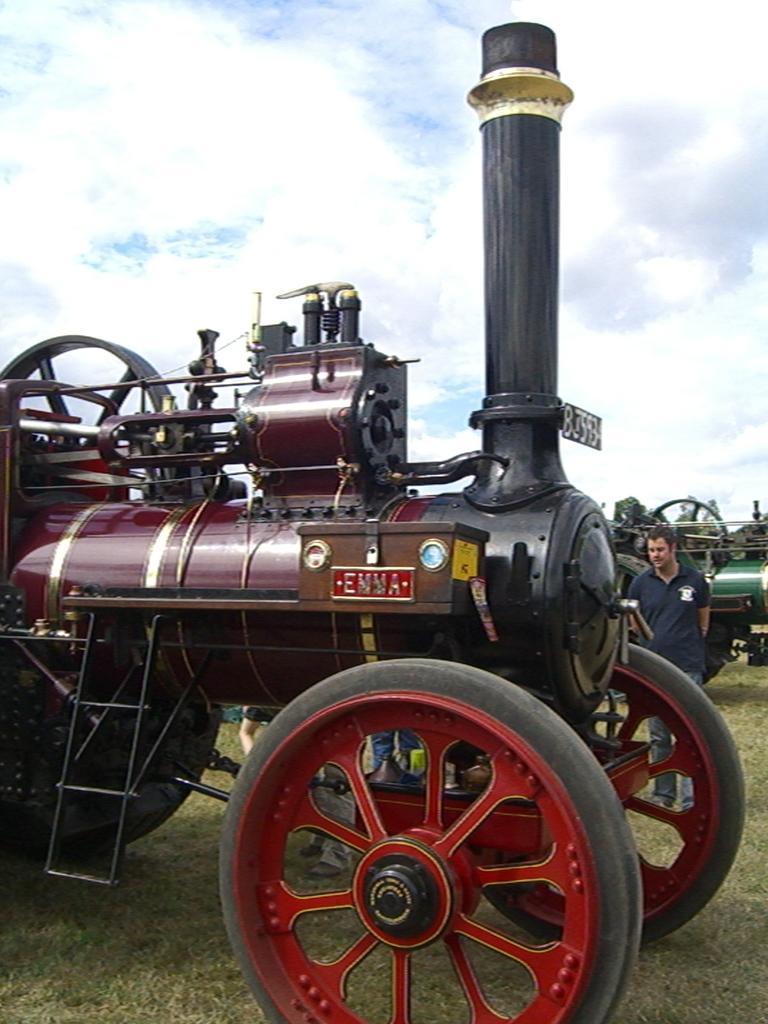Can you describe this image briefly? In this image I can see a steam engine visible in the foreground, beside the engine I can see a person and I can see another steam engine on the right side ,at the top I can see the sky. 